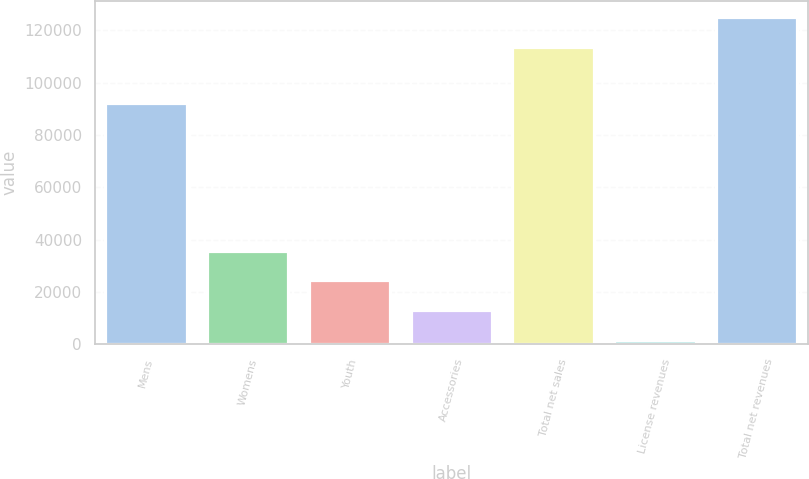Convert chart to OTSL. <chart><loc_0><loc_0><loc_500><loc_500><bar_chart><fcel>Mens<fcel>Womens<fcel>Youth<fcel>Accessories<fcel>Total net sales<fcel>License revenues<fcel>Total net revenues<nl><fcel>92197<fcel>35790.5<fcel>24415<fcel>13039.5<fcel>113755<fcel>1664<fcel>125130<nl></chart> 